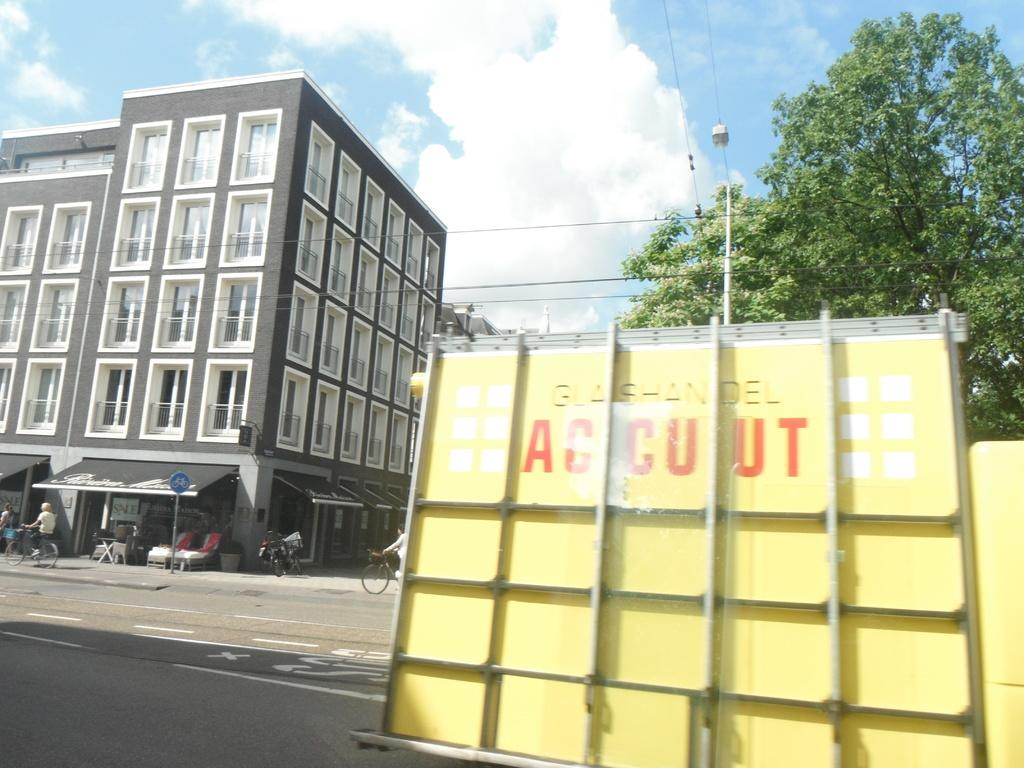What is located in the foreground of the image? There is a vehicle in the foreground of the image. Can you describe the people in the image? There are people in the image. What type of structures can be seen in the image? There are stalls in the image. What can be seen in the background of the image? There are buildings, trees, and the sky visible in the background of the image. How many spiders are crawling on the vehicle in the image? There are no spiders visible on the vehicle in the image. What order are the people following in the image? There is no indication of any specific order that the people are following in the image. 